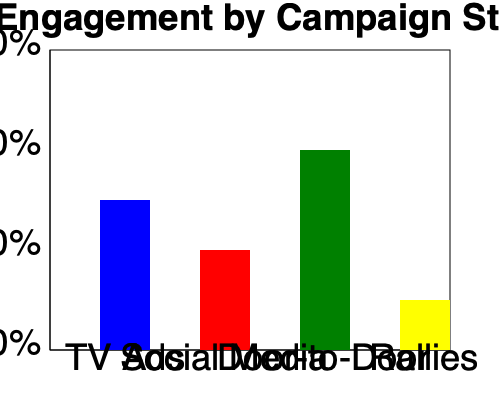Based on the bar graph showing voter engagement by campaign strategy, which method appears to be the most effective, and how might this data be potentially misleading for political campaign managers? To answer this question, we need to analyze the graph and consider potential limitations:

1. Interpret the graph:
   - The y-axis represents the percentage of voter engagement.
   - The x-axis shows four different campaign strategies: TV Ads, Social Media, Door-to-Door, and Rallies.

2. Identify the most effective strategy:
   - Door-to-Door campaigning shows the highest bar, reaching about 40% voter engagement.
   - TV Ads come second, with around 30% engagement.
   - Social Media is third, with about 20% engagement.
   - Rallies show the lowest engagement at approximately 10%.

3. Consider potential misleading aspects:
   a) Sample bias: The data might not represent the entire population accurately.
   b) Correlation vs. causation: High engagement doesn't necessarily mean more votes or support.
   c) Cost-effectiveness: The graph doesn't show the resources required for each strategy.
   d) Quality of engagement: The depth or impact of engagement isn't reflected.
   e) Regional variations: Effectiveness may vary in different areas.
   f) Time frame: The graph doesn't show how engagement changes over time.
   g) Definition of "engagement": This could vary between strategies, making direct comparisons problematic.

4. Skeptical perspective:
   - As a skeptical resident, one might question the source of this data and its potential biases.
   - The simplicity of the graph might oversimplify complex political dynamics.
   - The effectiveness of strategies could vary significantly based on local context and specific campaign goals.
Answer: Door-to-Door campaigning appears most effective, but the data could be misleading due to potential sample bias, lack of cost-effectiveness information, varying definitions of engagement, and oversimplification of complex political dynamics. 